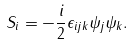Convert formula to latex. <formula><loc_0><loc_0><loc_500><loc_500>S _ { i } = - \frac { i } { 2 } \epsilon _ { i j k } \psi _ { j } \psi _ { k } .</formula> 